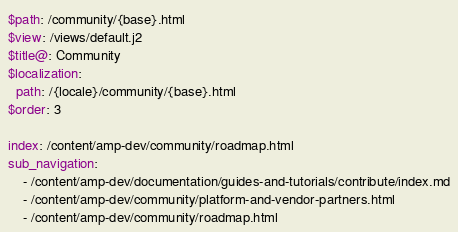<code> <loc_0><loc_0><loc_500><loc_500><_YAML_>$path: /community/{base}.html
$view: /views/default.j2
$title@: Community
$localization:
  path: /{locale}/community/{base}.html
$order: 3

index: /content/amp-dev/community/roadmap.html
sub_navigation:
    - /content/amp-dev/documentation/guides-and-tutorials/contribute/index.md
    - /content/amp-dev/community/platform-and-vendor-partners.html
    - /content/amp-dev/community/roadmap.html
</code> 